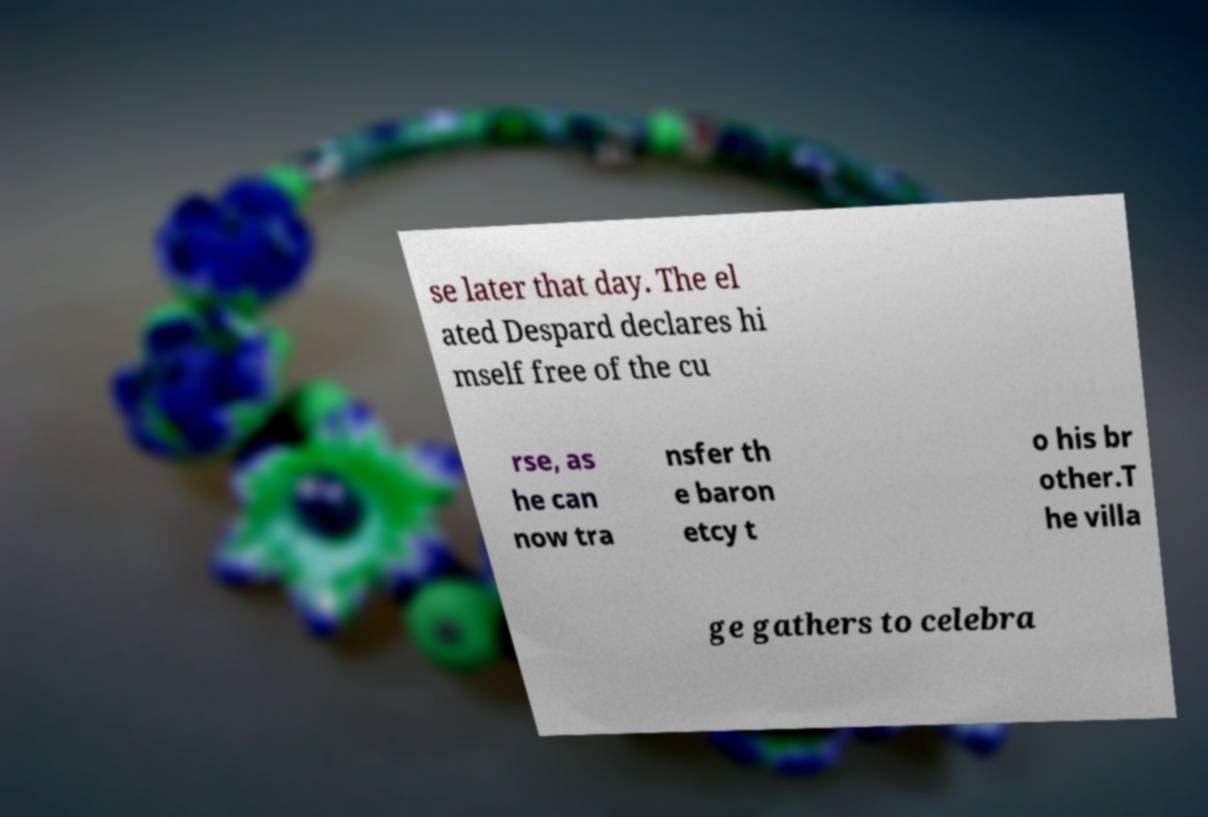Please read and relay the text visible in this image. What does it say? se later that day. The el ated Despard declares hi mself free of the cu rse, as he can now tra nsfer th e baron etcy t o his br other.T he villa ge gathers to celebra 